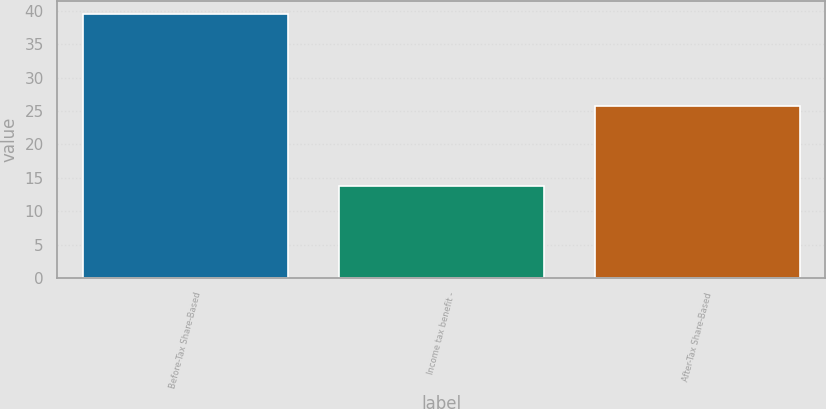Convert chart. <chart><loc_0><loc_0><loc_500><loc_500><bar_chart><fcel>Before-Tax Share-Based<fcel>Income tax benefit -<fcel>After-Tax Share-Based<nl><fcel>39.5<fcel>13.8<fcel>25.7<nl></chart> 